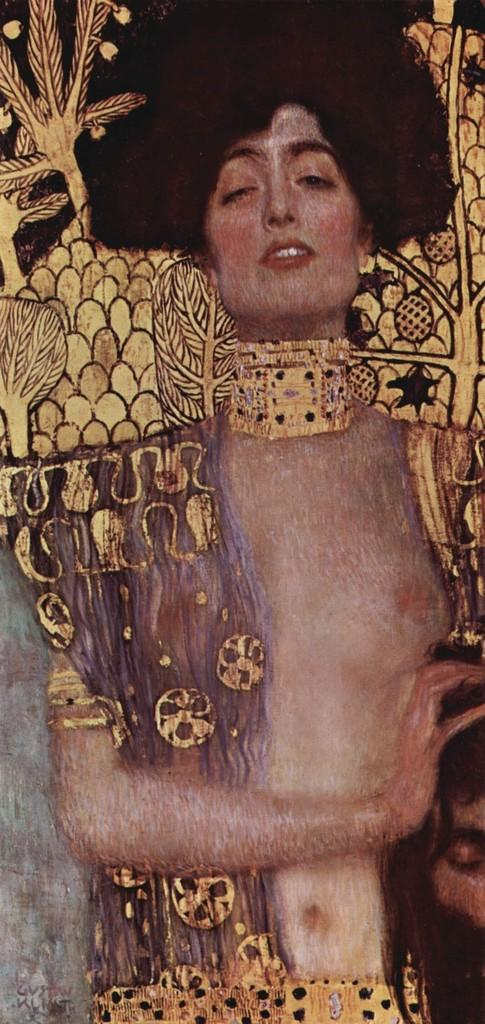What type of art medium is used in the image? The image is an oil painting. What is the main subject of the oil painting? The oil painting depicts a person. What color is the curtain behind the person in the oil painting? There is no curtain mentioned in the provided facts, so we cannot determine the color of any curtain in the image. What historical event is the person in the oil painting participating in? The provided facts do not mention any historical event, so we cannot determine if the person is participating in any historical event. What is the relationship between the person in the oil painting and the artist who created the painting? The provided facts do not mention any relationship between the person in the oil painting and the artist who created the painting, so we cannot determine their relationship. 